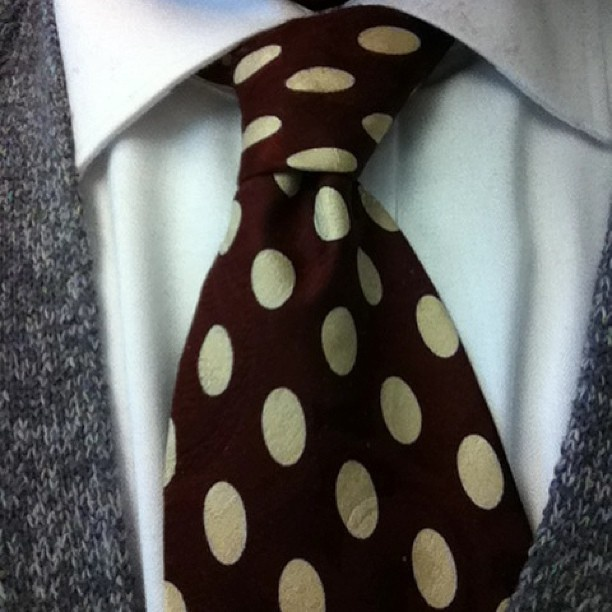Describe the objects in this image and their specific colors. I can see people in black, gray, darkgray, lightgray, and lightblue tones and tie in gray, black, tan, and darkgray tones in this image. 